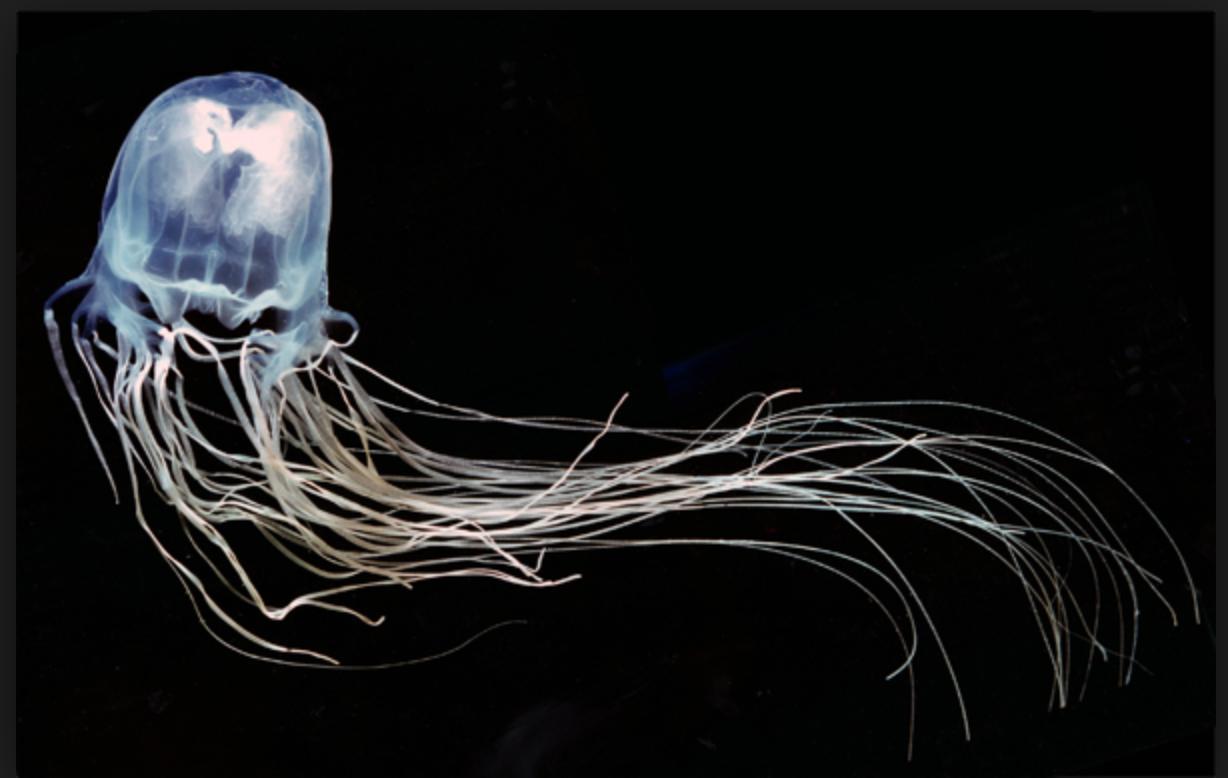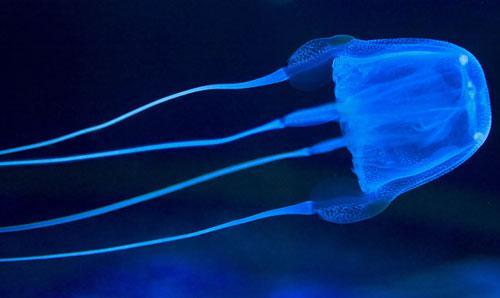The first image is the image on the left, the second image is the image on the right. Analyze the images presented: Is the assertion "There are exactly two jellyfish and no humans, and at least one jellyfish is facing to the right." valid? Answer yes or no. Yes. 